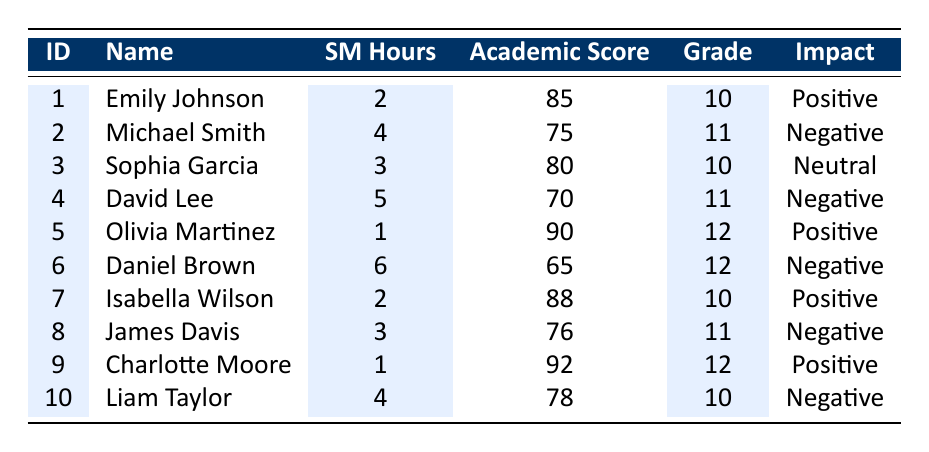What is the academic performance score of Olivia Martinez? Olivia Martinez is listed in the table with an academic performance score of 90.
Answer: 90 How many students spent more than 4 hours on social media? The table shows David Lee with 5 hours, Daniel Brown with 6 hours, and Michael Smith with 4 hours. Only David Lee and Daniel Brown spent more than 4 hours, totaling 2 students.
Answer: 2 Who has the lowest academic performance score, and what is that score? Scanning through the table, Daniel Brown has the lowest score of 65, which is the last entry in the academic performance score column.
Answer: 65 Is the impact on academic performance always negative when students spend more than 4 hours on social media? Checking the table, David Lee and Daniel Brown both spent more than 4 hours and have negative impacts. However, Michael Smith, who spent 4 hours, also has a negative impact. Therefore, all three with high social media hours show negative impact; hence, the statement is true.
Answer: Yes What is the average academic performance score of students with a positive impact? The students with a positive impact are Emily Johnson (85), Olivia Martinez (90), Isabella Wilson (88), and Charlotte Moore (92). Adding these scores gives 85 + 90 + 88 + 92 = 355. Dividing by the 4 students gives an average of 355 / 4 = 88.75.
Answer: 88.75 Are there more students with a negative impact or a positive impact on academic performance? Counting the impacts, there are 4 students with a negative impact (Michael Smith, David Lee, Daniel Brown, and Liam Taylor) and 4 students with a positive impact (Emily Johnson, Olivia Martinez, Isabella Wilson, and Charlotte Moore). Therefore, the numbers are equal.
Answer: No Which grade has the highest number of students with a negative impact? The students in grade 10 are Liam Taylor, Michael Smith, and David Lee. In grade 11, there are Michael Smith, David Lee, and James Davis. Hence, the grade with the highest number of students with a negative impact is grade 11, with 2 students.
Answer: Grade 11 How many students achieved an academic performance score of 80 or higher? From the table, the students with scores of 80 or higher are Emily Johnson (85), Sophia Garcia (80), Olivia Martinez (90), Isabella Wilson (88), and Charlotte Moore (92). Counting these gives a total of 5 students.
Answer: 5 